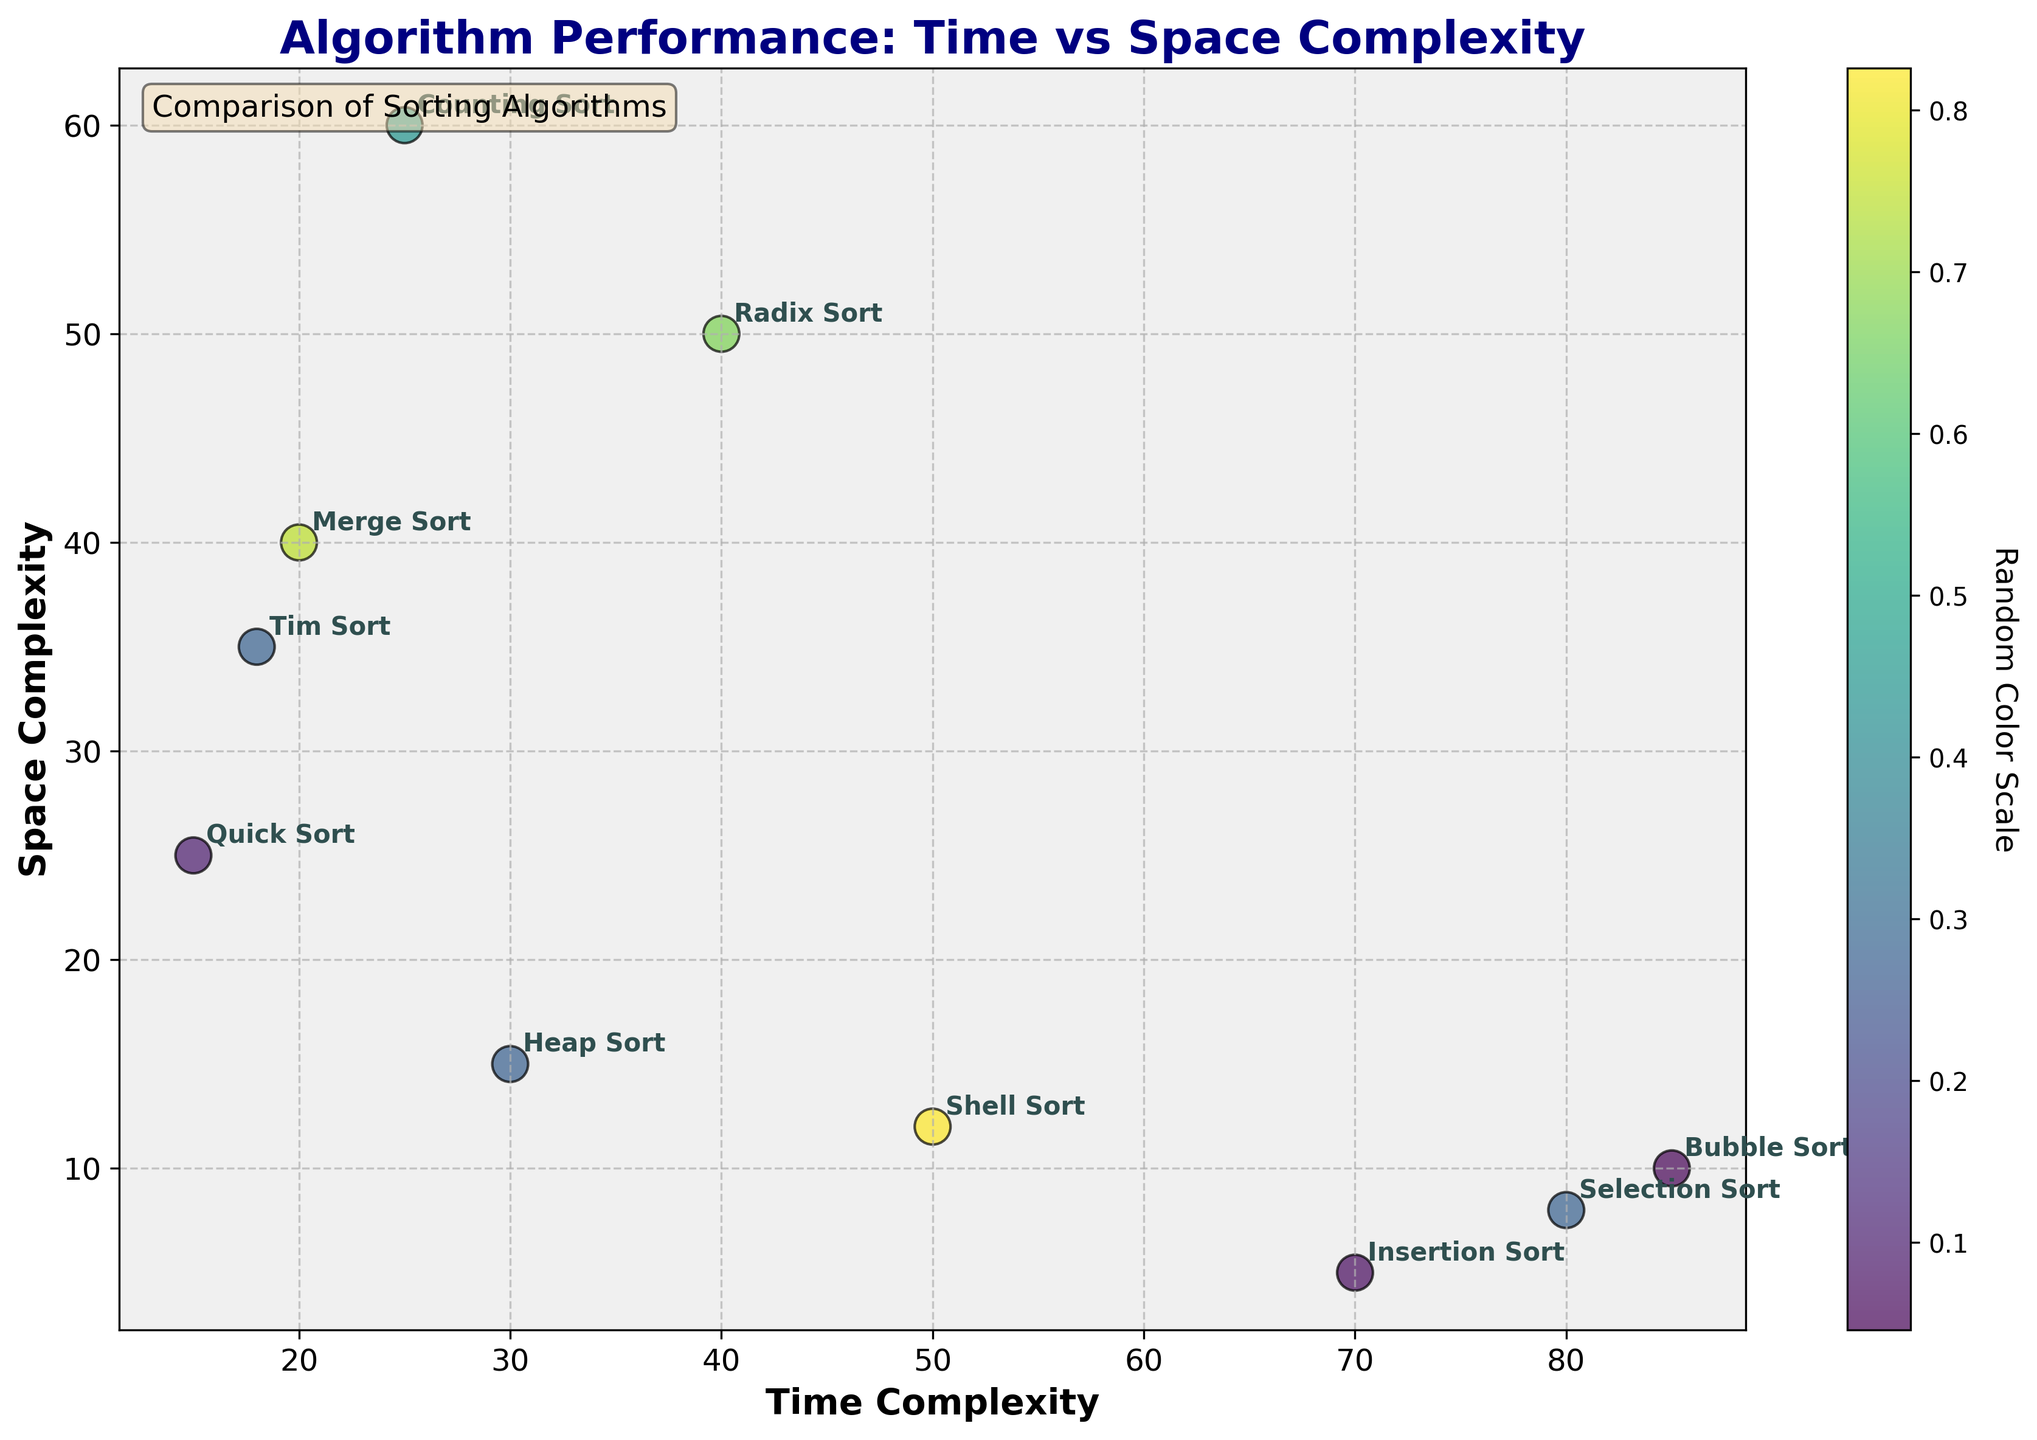What is the title of the figure? The title is typically located at the top center of the figure, prominently displayed. In this case, the title is "Algorithm Performance: Time vs Space Complexity".
Answer: Algorithm Performance: Time vs Space Complexity How many sorting algorithms are compared in the figure? The figure includes one data point for each sorting algorithm listed in the provided data. By counting these data points, we see there are 10.
Answer: 10 Which algorithm has the highest time complexity? Look at the x-axis (Time Complexity) and find the highest value among the data points. The point with the highest x-coordinate is Bubble Sort with a value of 85.
Answer: Bubble Sort What is the lowest space complexity value, and which algorithm does it belong to? Look at the y-axis (Space Complexity) and find the lowest value. The point with the lowest y-coordinate is Insertion Sort with a value of 5.
Answer: 5, Insertion Sort Which algorithm has a higher space complexity: Radix Sort or Counting Sort? Locate the points for Radix Sort and Counting Sort, then compare their y-coordinates. Radix Sort has a space complexity of 50, while Counting Sort has 60.
Answer: Counting Sort What's the average time complexity of Merge Sort, Quick Sort, and Tim Sort? Sum their time complexity values (20 for Merge Sort, 15 for Quick Sort, 18 for Tim Sort) and divide by 3. (20 + 15 + 18) / 3 = 53 / 3 ≈ 17.67
Answer: 17.67 Which sorting algorithms fall into the lower-left quadrant of the figure (i.e., low time and space complexity)? Focus on the part of the figure where both the x and y values are relatively small. Quick Sort (15, 25) and Tim Sort (18, 35) fall into this quadrant.
Answer: Quick Sort, Tim Sort Arrange Bubble Sort, Selection Sort, and Shell Sort in ascending order of their time complexity. Compare their time complexity values: Bubble Sort (85), Selection Sort (80), and Shell Sort (50). The ascending order is Shell Sort, Selection Sort, Bubble Sort.
Answer: Shell Sort, Selection Sort, Bubble Sort Identify the algorithms that have greater space complexity than time complexity. Compare each algorithm’s x (Time Complexity) and y (Space Complexity) values and find those where y > x. Radix Sort (40, 50) and Counting Sort (25, 60) meet this criterion.
Answer: Radix Sort, Counting Sort 